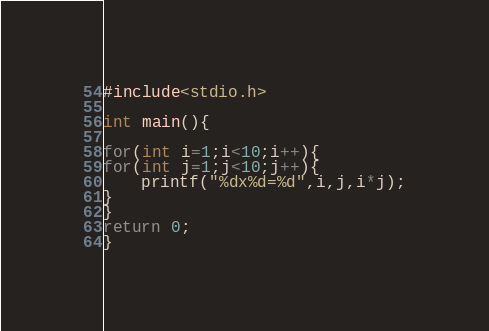Convert code to text. <code><loc_0><loc_0><loc_500><loc_500><_C++_>#include<stdio.h>
 
int main(){
 
for(int i=1;i<10;i++){
for(int j=1;j<10;j++){
    printf("%dx%d=%d",i,j,i*j);
}
}
return 0;
}</code> 